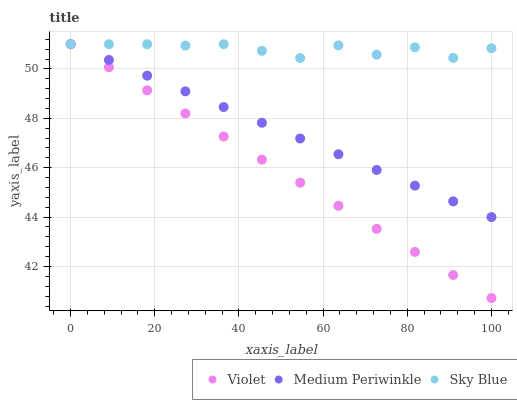Does Violet have the minimum area under the curve?
Answer yes or no. Yes. Does Sky Blue have the maximum area under the curve?
Answer yes or no. Yes. Does Medium Periwinkle have the minimum area under the curve?
Answer yes or no. No. Does Medium Periwinkle have the maximum area under the curve?
Answer yes or no. No. Is Medium Periwinkle the smoothest?
Answer yes or no. Yes. Is Sky Blue the roughest?
Answer yes or no. Yes. Is Violet the smoothest?
Answer yes or no. No. Is Violet the roughest?
Answer yes or no. No. Does Violet have the lowest value?
Answer yes or no. Yes. Does Medium Periwinkle have the lowest value?
Answer yes or no. No. Does Violet have the highest value?
Answer yes or no. Yes. Does Sky Blue intersect Violet?
Answer yes or no. Yes. Is Sky Blue less than Violet?
Answer yes or no. No. Is Sky Blue greater than Violet?
Answer yes or no. No. 